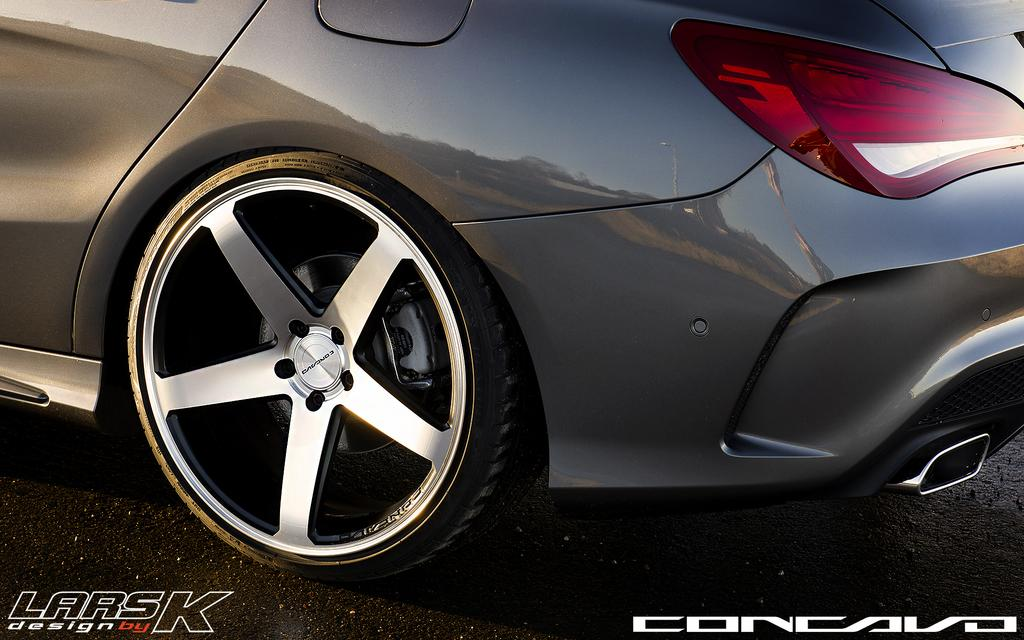What is the main subject of the image? The main subject of the image is a car. What are the wheels used for on the car? The wheels are used for the car to move and navigate on different surfaces. Can you describe the headlight on the car? There is a headlight on the right side of the car, which is used for illuminating the road ahead during low-light conditions. What type of doctor is examining the car in the image? There is no doctor present in the image; it only features a car with wheels and a headlight. 